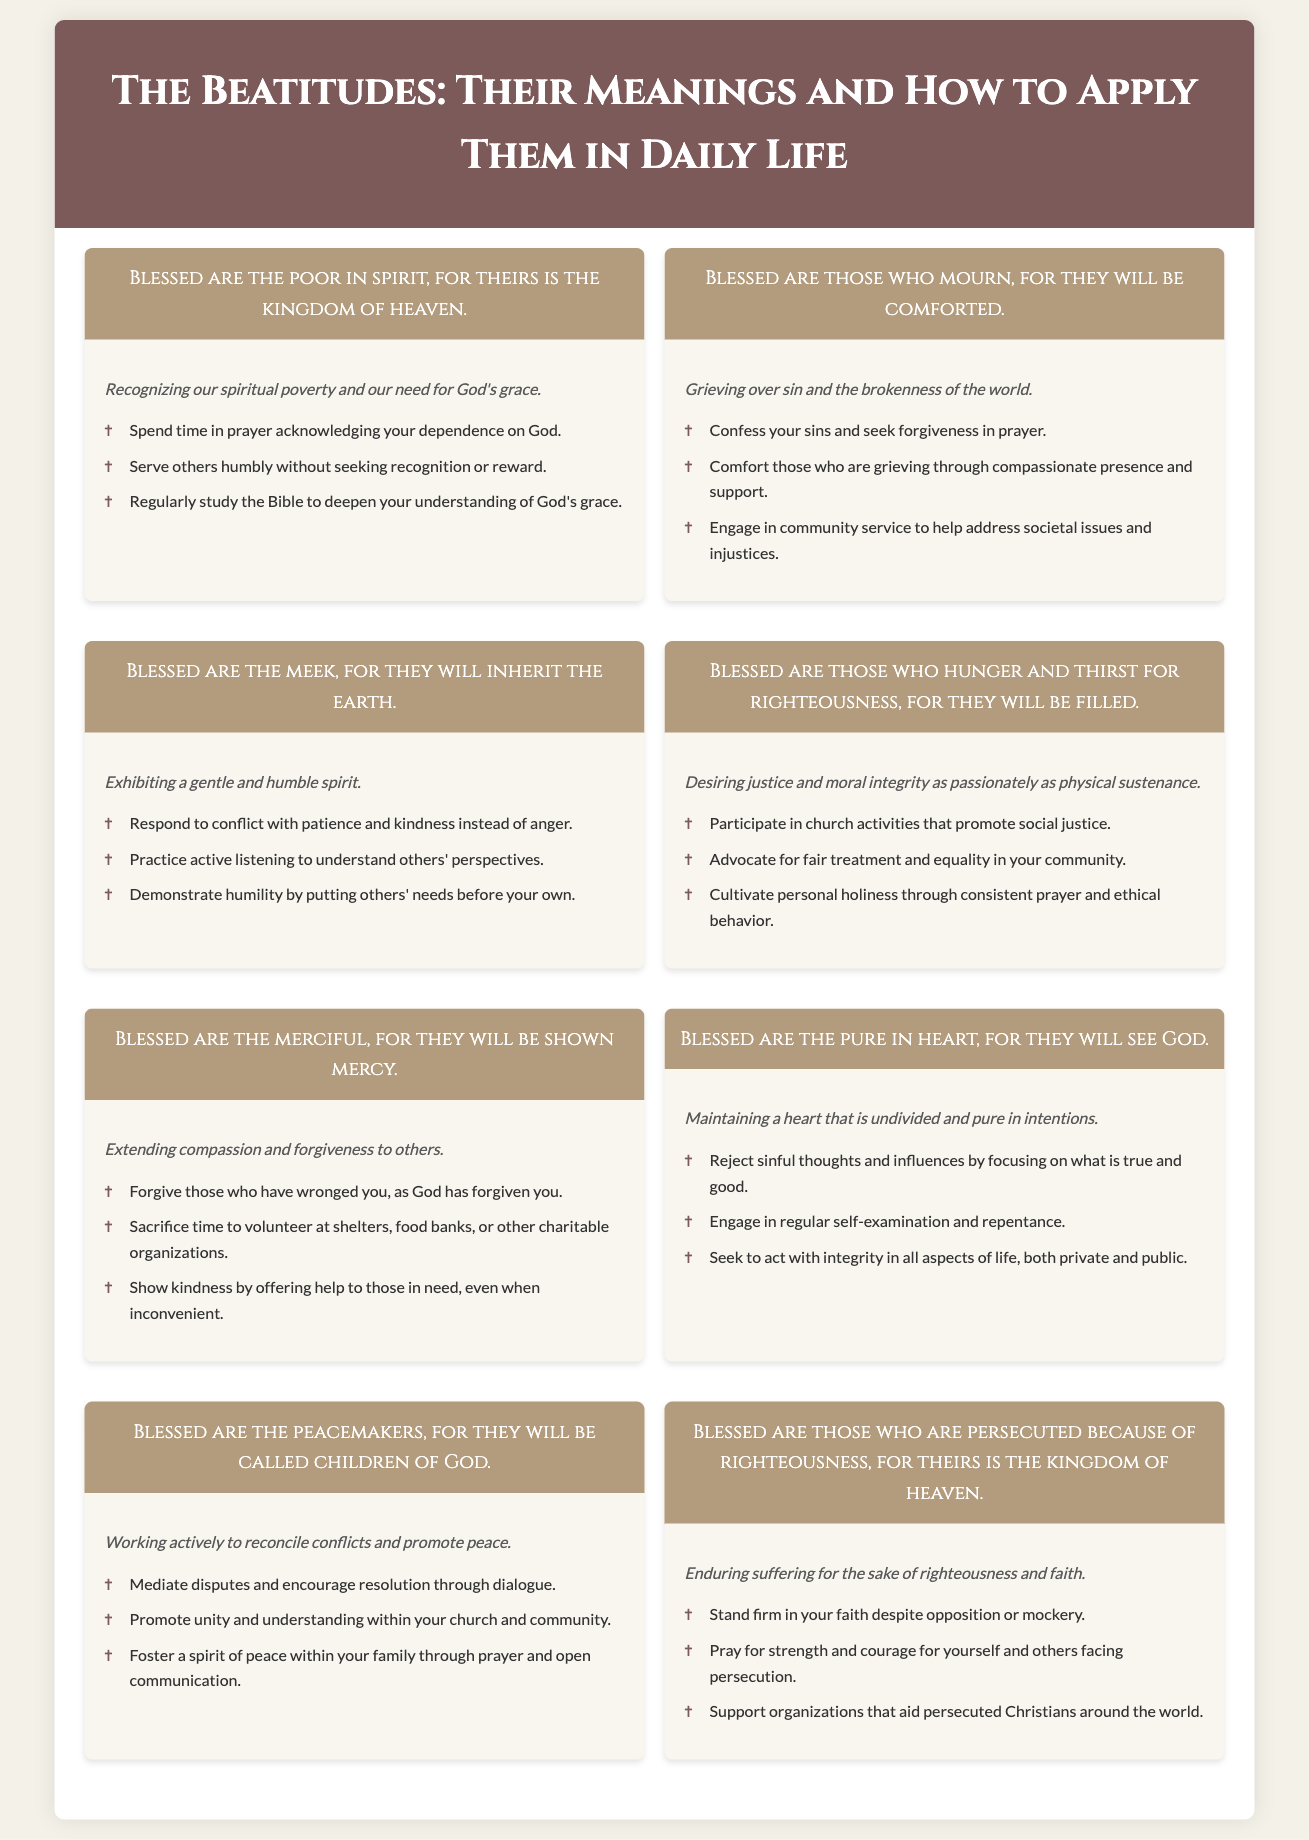What is the first Beatitude? The first Beatitude states "Blessed are the poor in spirit, for theirs is the kingdom of heaven."
Answer: Blessed are the poor in spirit What does the second Beatitude mean? The meaning of the second Beatitude is "Grieving over sin and the brokenness of the world."
Answer: Grieving over sin and the brokenness of the world How many Beatitudes are there in total? There are eight Beatitudes presented in the document.
Answer: Eight What is one application of being merciful? The document suggests "Forgive those who have wronged you, as God has forgiven you."
Answer: Forgive those who have wronged you What do the pure in heart receive according to the Beatitudes? The pure in heart will see God.
Answer: They will see God Why are peacemakers called children of God? Peacemakers are called children of God because they work actively to reconcile conflicts and promote peace.
Answer: They will be called children of God What do those who hunger and thirst for righteousness seek? They desire justice and moral integrity as passionately as physical sustenance.
Answer: Justice and moral integrity What is a common theme among the Beatitudes? A common theme is the emphasis on humility and dependence on God.
Answer: Humility and dependence on God 